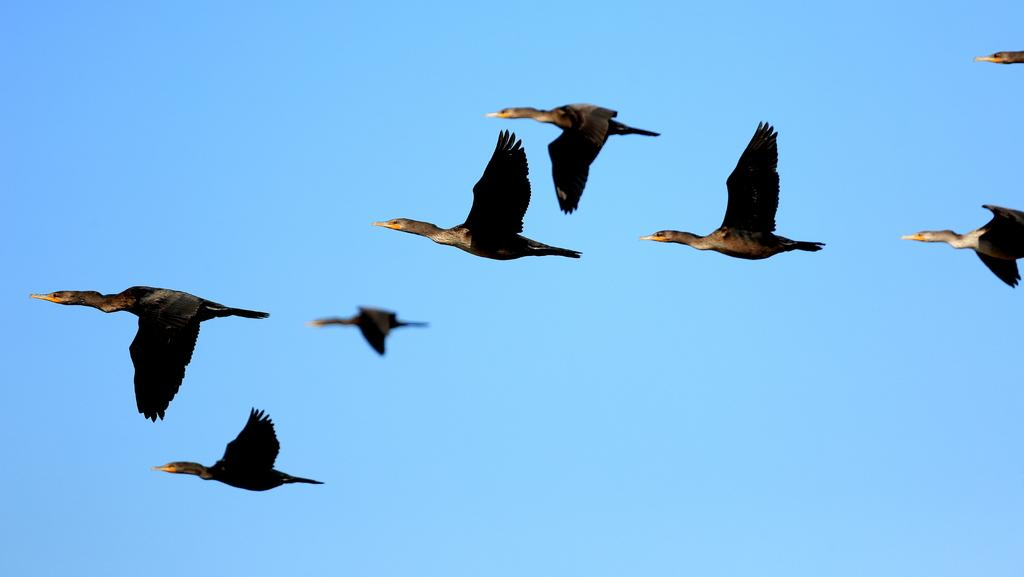What type of animals can be seen in the image? There are birds in the image. What colors are the birds? The birds are black and brown in color. What are the birds doing in the image? The birds are flying in the sky. What is visible in the background of the image? The sky is visible in the background of the image. What is the condition of the sky in the image? The sky is clear in the image. What suggestion does the church make in the image? There is no church present in the image, so it cannot make any suggestions. How hot is the image? The image is not a physical object, so it cannot have a temperature. 